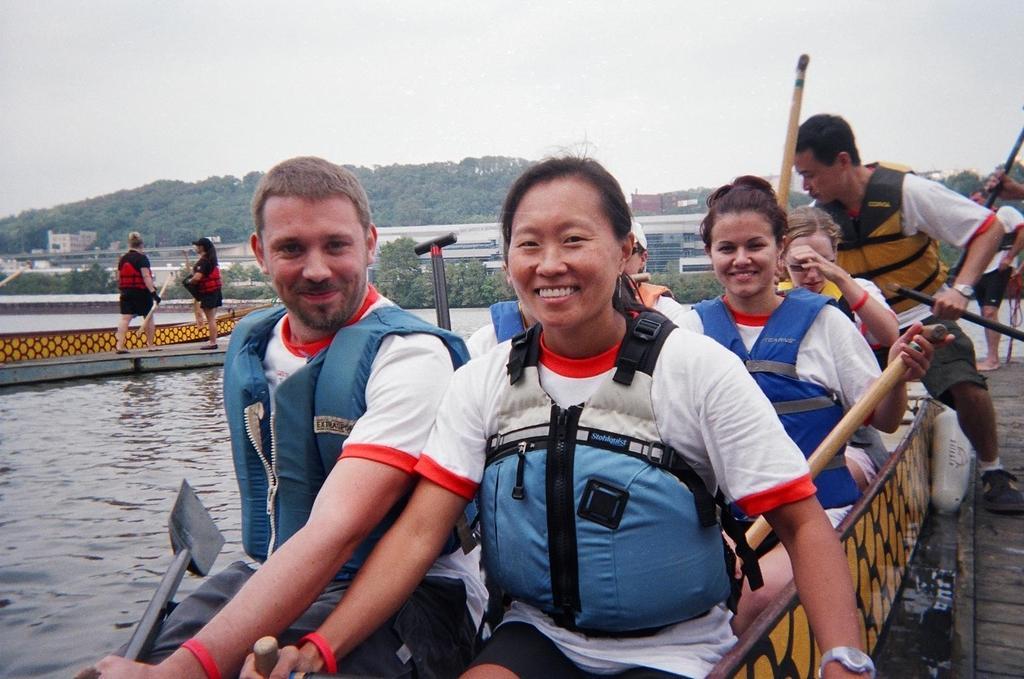Please provide a concise description of this image. In the center of the image there are people sitting in the boat. In the background of the image there are trees,buildings. At the top of the image there is sky. To the left side of the image there is water. To the right side of the image there is a wooden flooring. 